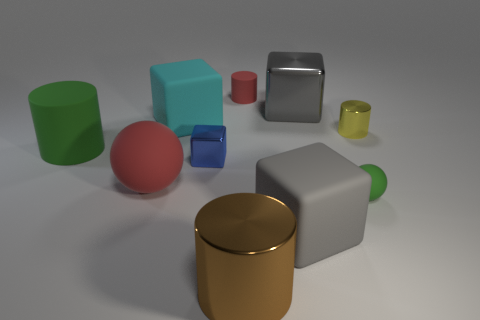Subtract 1 cubes. How many cubes are left? 3 Subtract all spheres. How many objects are left? 8 Add 5 brown objects. How many brown objects are left? 6 Add 6 purple rubber things. How many purple rubber things exist? 6 Subtract 0 blue cylinders. How many objects are left? 10 Subtract all metallic blocks. Subtract all small yellow cylinders. How many objects are left? 7 